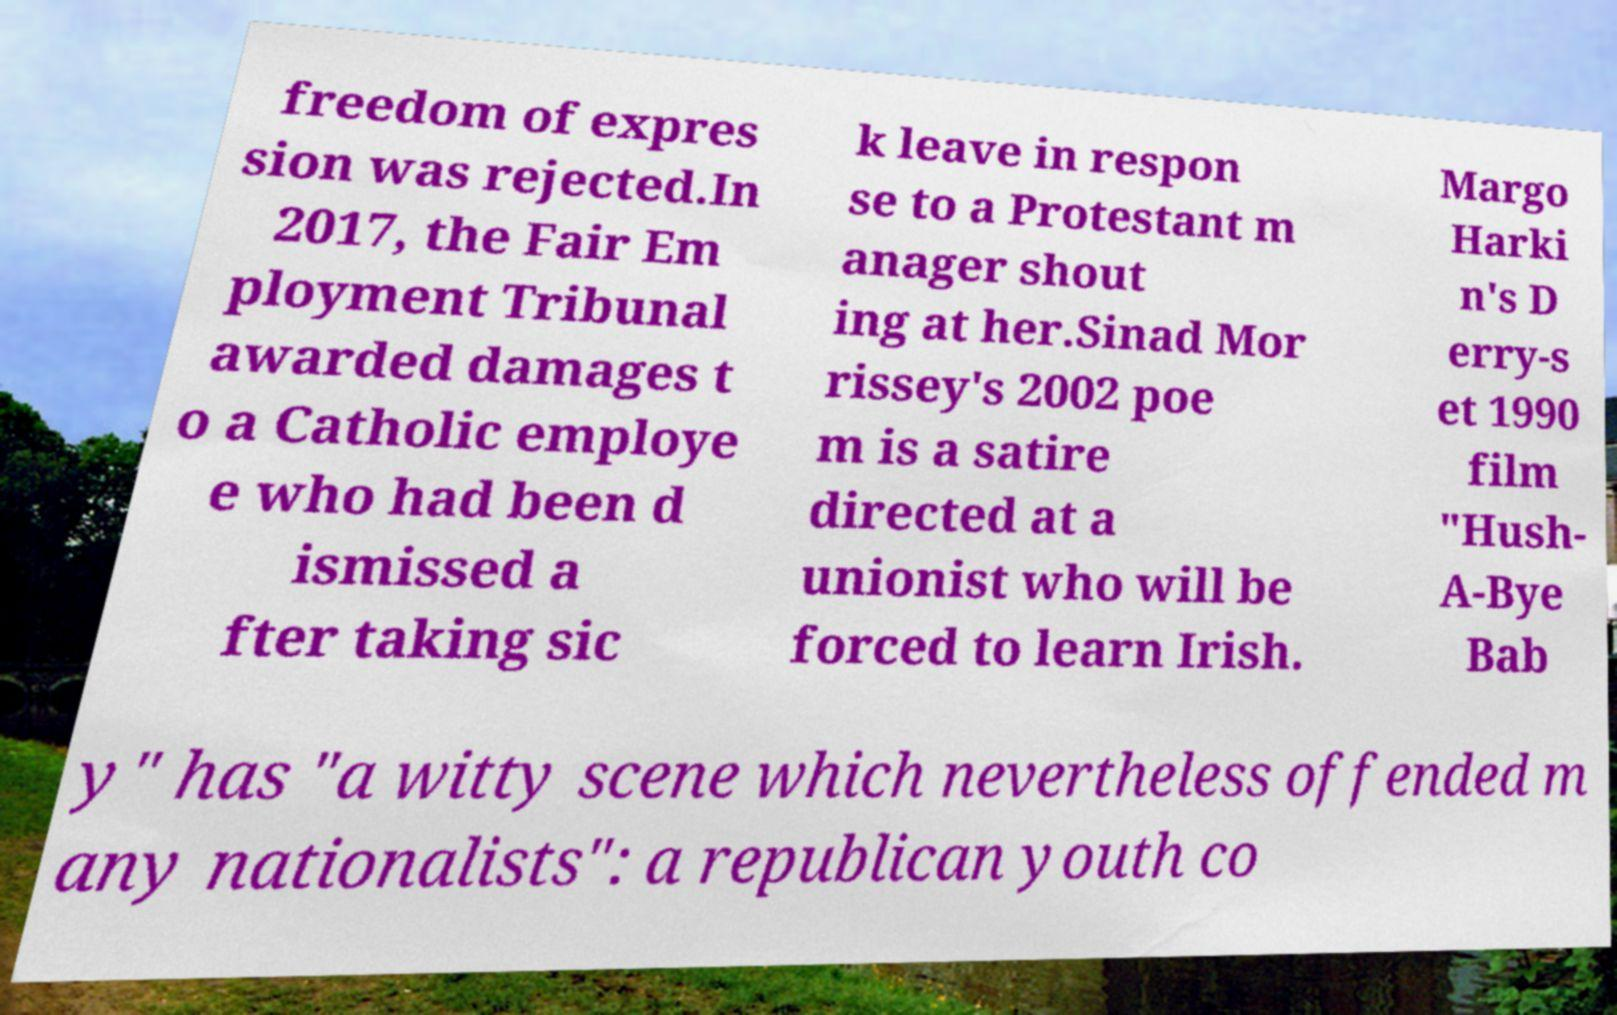There's text embedded in this image that I need extracted. Can you transcribe it verbatim? freedom of expres sion was rejected.In 2017, the Fair Em ployment Tribunal awarded damages t o a Catholic employe e who had been d ismissed a fter taking sic k leave in respon se to a Protestant m anager shout ing at her.Sinad Mor rissey's 2002 poe m is a satire directed at a unionist who will be forced to learn Irish. Margo Harki n's D erry-s et 1990 film "Hush- A-Bye Bab y" has "a witty scene which nevertheless offended m any nationalists": a republican youth co 